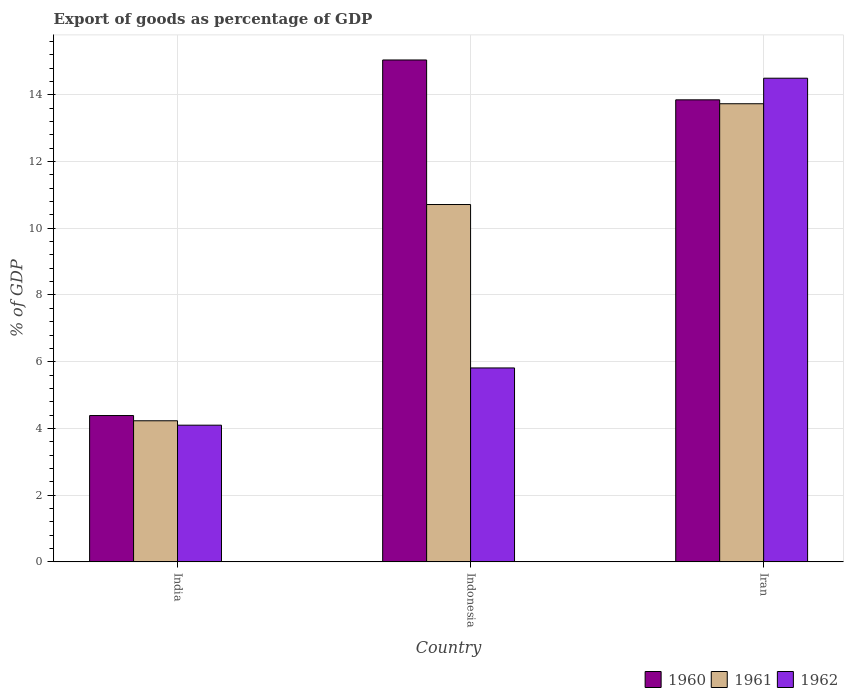How many different coloured bars are there?
Your answer should be very brief. 3. Are the number of bars on each tick of the X-axis equal?
Make the answer very short. Yes. What is the export of goods as percentage of GDP in 1961 in Indonesia?
Offer a terse response. 10.71. Across all countries, what is the maximum export of goods as percentage of GDP in 1962?
Your answer should be very brief. 14.5. Across all countries, what is the minimum export of goods as percentage of GDP in 1960?
Make the answer very short. 4.39. In which country was the export of goods as percentage of GDP in 1962 maximum?
Your answer should be very brief. Iran. What is the total export of goods as percentage of GDP in 1961 in the graph?
Give a very brief answer. 28.67. What is the difference between the export of goods as percentage of GDP in 1961 in Indonesia and that in Iran?
Make the answer very short. -3.02. What is the difference between the export of goods as percentage of GDP in 1962 in India and the export of goods as percentage of GDP in 1960 in Indonesia?
Your answer should be compact. -10.95. What is the average export of goods as percentage of GDP in 1960 per country?
Keep it short and to the point. 11.09. What is the difference between the export of goods as percentage of GDP of/in 1962 and export of goods as percentage of GDP of/in 1960 in India?
Your answer should be compact. -0.29. What is the ratio of the export of goods as percentage of GDP in 1961 in India to that in Indonesia?
Provide a succinct answer. 0.39. Is the difference between the export of goods as percentage of GDP in 1962 in Indonesia and Iran greater than the difference between the export of goods as percentage of GDP in 1960 in Indonesia and Iran?
Provide a succinct answer. No. What is the difference between the highest and the second highest export of goods as percentage of GDP in 1962?
Offer a very short reply. -1.72. What is the difference between the highest and the lowest export of goods as percentage of GDP in 1962?
Give a very brief answer. 10.4. In how many countries, is the export of goods as percentage of GDP in 1961 greater than the average export of goods as percentage of GDP in 1961 taken over all countries?
Provide a short and direct response. 2. Is the sum of the export of goods as percentage of GDP in 1961 in India and Iran greater than the maximum export of goods as percentage of GDP in 1962 across all countries?
Your answer should be very brief. Yes. What does the 2nd bar from the left in Indonesia represents?
Offer a very short reply. 1961. Is it the case that in every country, the sum of the export of goods as percentage of GDP in 1962 and export of goods as percentage of GDP in 1961 is greater than the export of goods as percentage of GDP in 1960?
Provide a short and direct response. Yes. How many bars are there?
Provide a short and direct response. 9. Are all the bars in the graph horizontal?
Ensure brevity in your answer.  No. How many countries are there in the graph?
Your answer should be compact. 3. Does the graph contain grids?
Offer a terse response. Yes. Where does the legend appear in the graph?
Make the answer very short. Bottom right. How many legend labels are there?
Provide a succinct answer. 3. How are the legend labels stacked?
Ensure brevity in your answer.  Horizontal. What is the title of the graph?
Make the answer very short. Export of goods as percentage of GDP. Does "2014" appear as one of the legend labels in the graph?
Keep it short and to the point. No. What is the label or title of the Y-axis?
Keep it short and to the point. % of GDP. What is the % of GDP in 1960 in India?
Your response must be concise. 4.39. What is the % of GDP in 1961 in India?
Offer a terse response. 4.23. What is the % of GDP of 1962 in India?
Keep it short and to the point. 4.1. What is the % of GDP of 1960 in Indonesia?
Give a very brief answer. 15.04. What is the % of GDP of 1961 in Indonesia?
Your response must be concise. 10.71. What is the % of GDP in 1962 in Indonesia?
Provide a succinct answer. 5.81. What is the % of GDP in 1960 in Iran?
Your response must be concise. 13.85. What is the % of GDP of 1961 in Iran?
Your answer should be very brief. 13.73. What is the % of GDP of 1962 in Iran?
Give a very brief answer. 14.5. Across all countries, what is the maximum % of GDP in 1960?
Your response must be concise. 15.04. Across all countries, what is the maximum % of GDP of 1961?
Offer a terse response. 13.73. Across all countries, what is the maximum % of GDP of 1962?
Give a very brief answer. 14.5. Across all countries, what is the minimum % of GDP in 1960?
Your answer should be very brief. 4.39. Across all countries, what is the minimum % of GDP of 1961?
Keep it short and to the point. 4.23. Across all countries, what is the minimum % of GDP in 1962?
Your response must be concise. 4.1. What is the total % of GDP of 1960 in the graph?
Ensure brevity in your answer.  33.28. What is the total % of GDP in 1961 in the graph?
Your answer should be very brief. 28.67. What is the total % of GDP in 1962 in the graph?
Make the answer very short. 24.41. What is the difference between the % of GDP of 1960 in India and that in Indonesia?
Your answer should be compact. -10.66. What is the difference between the % of GDP in 1961 in India and that in Indonesia?
Your answer should be very brief. -6.48. What is the difference between the % of GDP of 1962 in India and that in Indonesia?
Provide a succinct answer. -1.72. What is the difference between the % of GDP in 1960 in India and that in Iran?
Provide a succinct answer. -9.46. What is the difference between the % of GDP of 1961 in India and that in Iran?
Provide a short and direct response. -9.5. What is the difference between the % of GDP in 1962 in India and that in Iran?
Offer a terse response. -10.4. What is the difference between the % of GDP in 1960 in Indonesia and that in Iran?
Make the answer very short. 1.19. What is the difference between the % of GDP of 1961 in Indonesia and that in Iran?
Provide a short and direct response. -3.02. What is the difference between the % of GDP in 1962 in Indonesia and that in Iran?
Provide a succinct answer. -8.68. What is the difference between the % of GDP in 1960 in India and the % of GDP in 1961 in Indonesia?
Keep it short and to the point. -6.32. What is the difference between the % of GDP of 1960 in India and the % of GDP of 1962 in Indonesia?
Provide a short and direct response. -1.43. What is the difference between the % of GDP in 1961 in India and the % of GDP in 1962 in Indonesia?
Provide a succinct answer. -1.58. What is the difference between the % of GDP in 1960 in India and the % of GDP in 1961 in Iran?
Make the answer very short. -9.35. What is the difference between the % of GDP of 1960 in India and the % of GDP of 1962 in Iran?
Your answer should be compact. -10.11. What is the difference between the % of GDP of 1961 in India and the % of GDP of 1962 in Iran?
Provide a succinct answer. -10.27. What is the difference between the % of GDP in 1960 in Indonesia and the % of GDP in 1961 in Iran?
Your response must be concise. 1.31. What is the difference between the % of GDP of 1960 in Indonesia and the % of GDP of 1962 in Iran?
Provide a succinct answer. 0.55. What is the difference between the % of GDP in 1961 in Indonesia and the % of GDP in 1962 in Iran?
Your response must be concise. -3.79. What is the average % of GDP in 1960 per country?
Make the answer very short. 11.09. What is the average % of GDP in 1961 per country?
Your response must be concise. 9.56. What is the average % of GDP in 1962 per country?
Keep it short and to the point. 8.14. What is the difference between the % of GDP of 1960 and % of GDP of 1961 in India?
Make the answer very short. 0.16. What is the difference between the % of GDP in 1960 and % of GDP in 1962 in India?
Offer a very short reply. 0.29. What is the difference between the % of GDP of 1961 and % of GDP of 1962 in India?
Keep it short and to the point. 0.13. What is the difference between the % of GDP of 1960 and % of GDP of 1961 in Indonesia?
Offer a terse response. 4.33. What is the difference between the % of GDP in 1960 and % of GDP in 1962 in Indonesia?
Offer a terse response. 9.23. What is the difference between the % of GDP in 1961 and % of GDP in 1962 in Indonesia?
Provide a succinct answer. 4.9. What is the difference between the % of GDP in 1960 and % of GDP in 1961 in Iran?
Your response must be concise. 0.12. What is the difference between the % of GDP of 1960 and % of GDP of 1962 in Iran?
Your response must be concise. -0.65. What is the difference between the % of GDP in 1961 and % of GDP in 1962 in Iran?
Your response must be concise. -0.77. What is the ratio of the % of GDP of 1960 in India to that in Indonesia?
Give a very brief answer. 0.29. What is the ratio of the % of GDP of 1961 in India to that in Indonesia?
Your response must be concise. 0.39. What is the ratio of the % of GDP of 1962 in India to that in Indonesia?
Ensure brevity in your answer.  0.7. What is the ratio of the % of GDP in 1960 in India to that in Iran?
Offer a very short reply. 0.32. What is the ratio of the % of GDP in 1961 in India to that in Iran?
Provide a succinct answer. 0.31. What is the ratio of the % of GDP in 1962 in India to that in Iran?
Provide a short and direct response. 0.28. What is the ratio of the % of GDP of 1960 in Indonesia to that in Iran?
Your answer should be very brief. 1.09. What is the ratio of the % of GDP of 1961 in Indonesia to that in Iran?
Your answer should be compact. 0.78. What is the ratio of the % of GDP of 1962 in Indonesia to that in Iran?
Keep it short and to the point. 0.4. What is the difference between the highest and the second highest % of GDP of 1960?
Ensure brevity in your answer.  1.19. What is the difference between the highest and the second highest % of GDP of 1961?
Your answer should be compact. 3.02. What is the difference between the highest and the second highest % of GDP in 1962?
Offer a terse response. 8.68. What is the difference between the highest and the lowest % of GDP in 1960?
Ensure brevity in your answer.  10.66. What is the difference between the highest and the lowest % of GDP of 1961?
Provide a short and direct response. 9.5. What is the difference between the highest and the lowest % of GDP in 1962?
Your response must be concise. 10.4. 